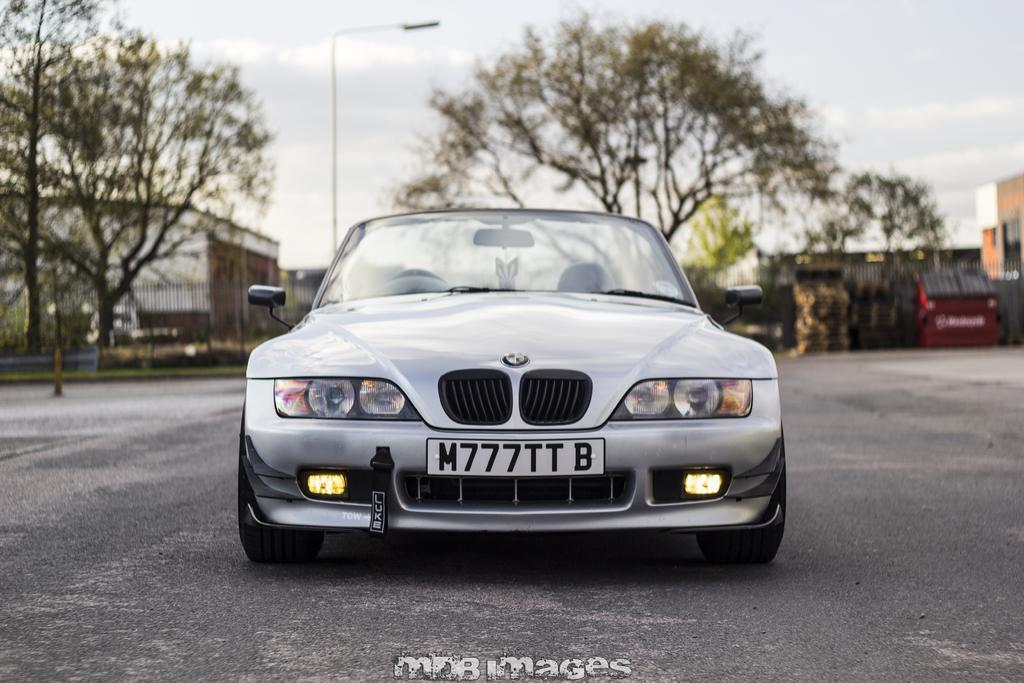In one or two sentences, can you explain what this image depicts? There is a gray color car on the road. In front of that, there is a watermark. In the background, there are trees, a fencing, a light attached to the pole, buildings and there are clouds in the sky. 